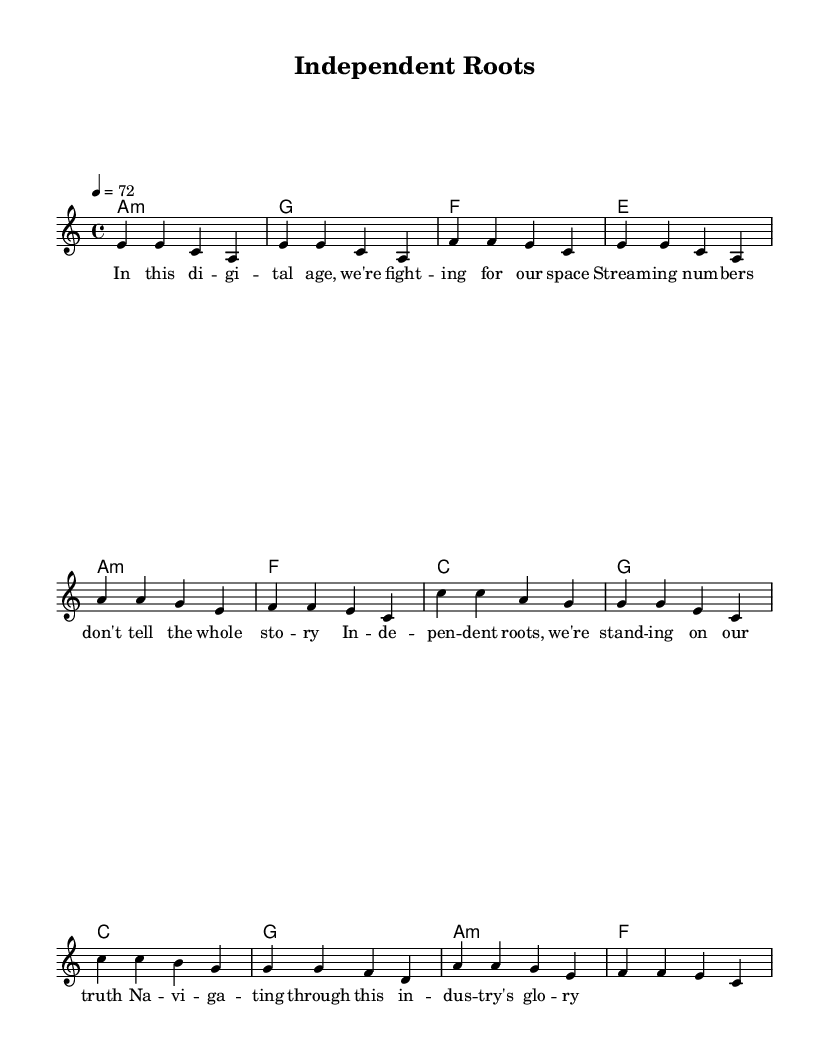What is the key signature of this music? The key signature is A minor, which has no sharps or flats.
Answer: A minor What is the time signature of this music? The time signature is 4/4, indicating four beats per measure.
Answer: 4/4 What is the tempo marking for this piece? The tempo marking indicates a speed of 72 beats per minute.
Answer: 72 What is the primary chord in the verse section? The primary chord in the verse section is A minor, as seen at the beginning of the chord progression.
Answer: A minor What is the melodic range of the lead voice? The melodic range of the lead voice spans from E to C, as evidenced by the notes listed in the score.
Answer: E to C How many measures are in the chorus section? The chorus section consists of four measures, as indicated by the number of chords specified.
Answer: 4 What lyrical theme is addressed in the song? The song addresses themes of independence and the challenges faced by artists in the digital age, reflecting a conscious reggae message.
Answer: Independence 